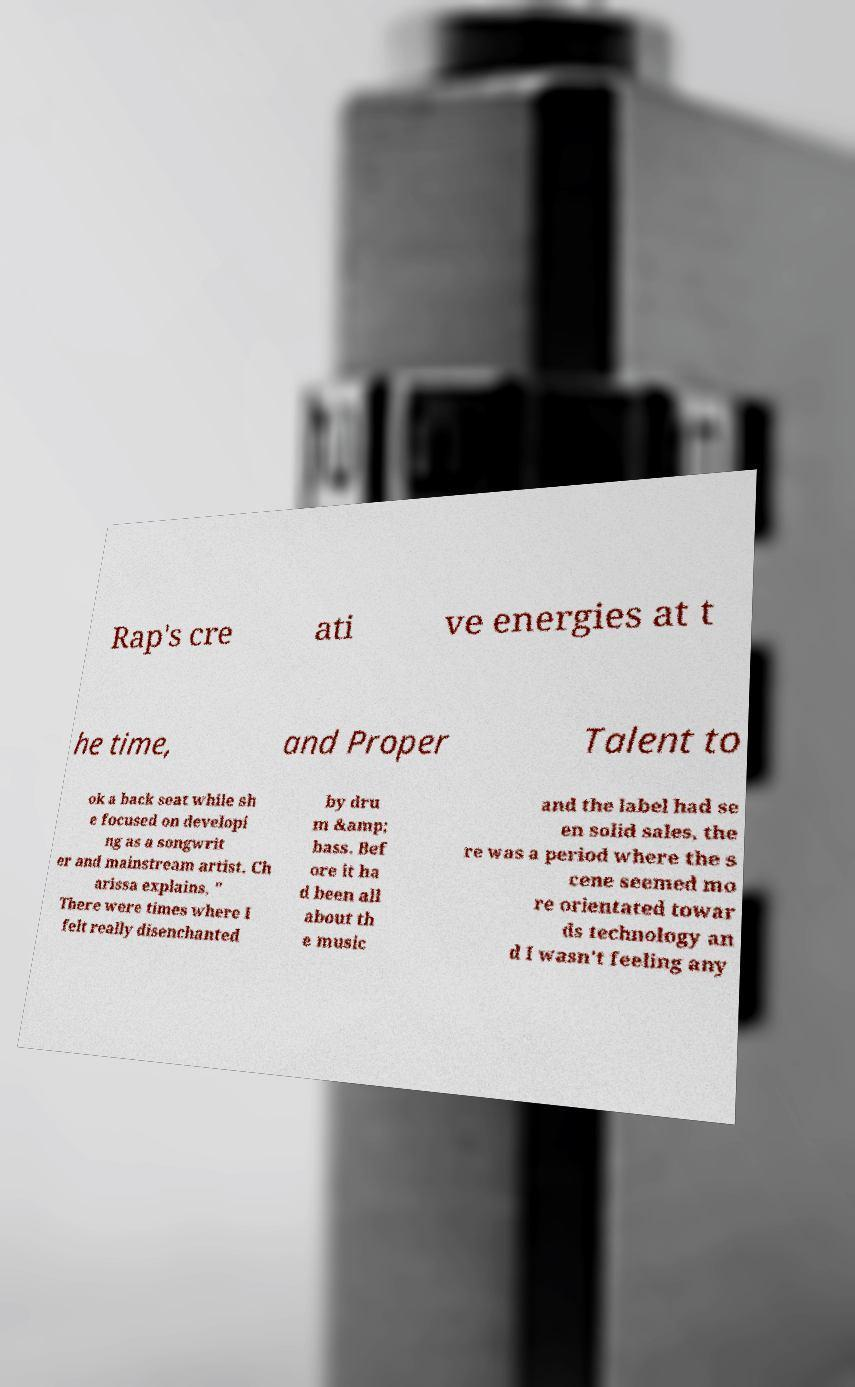Please identify and transcribe the text found in this image. Rap's cre ati ve energies at t he time, and Proper Talent to ok a back seat while sh e focused on developi ng as a songwrit er and mainstream artist. Ch arissa explains, " There were times where I felt really disenchanted by dru m &amp; bass. Bef ore it ha d been all about th e music and the label had se en solid sales, the re was a period where the s cene seemed mo re orientated towar ds technology an d I wasn't feeling any 